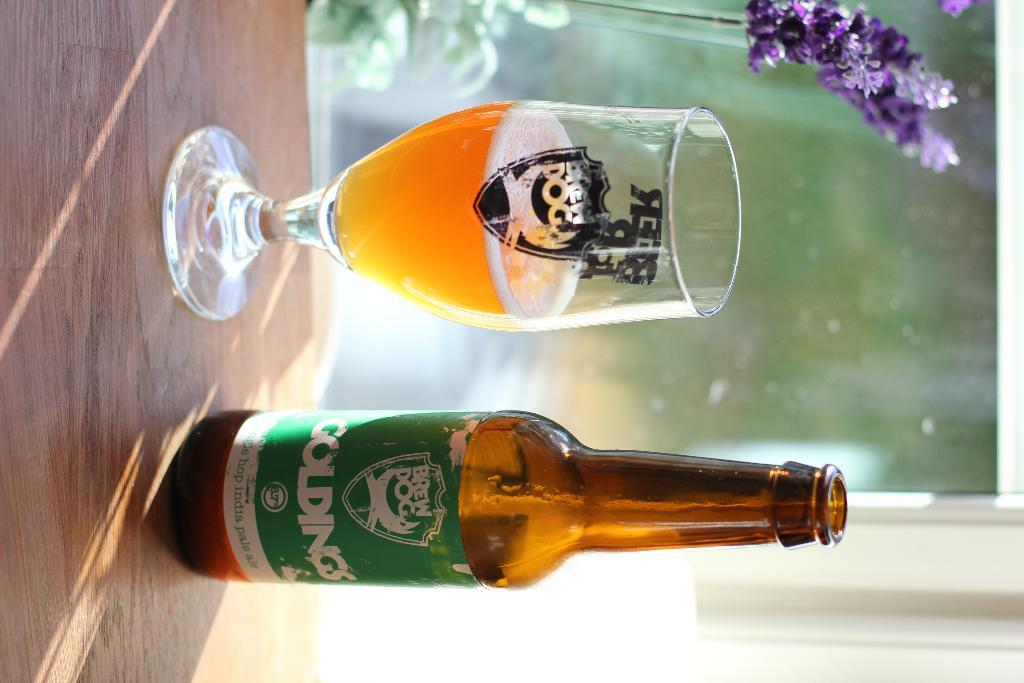<image>
Write a terse but informative summary of the picture. A bottle of Brew Dog brand beer sits on a table near some purple flowers. 